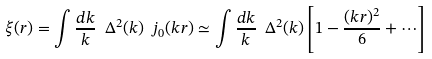<formula> <loc_0><loc_0><loc_500><loc_500>\xi ( r ) = \int \frac { d k } { k } \ \Delta ^ { 2 } ( k ) \ j _ { 0 } ( k r ) \simeq \int \frac { d k } { k } \ \Delta ^ { 2 } ( k ) \left [ 1 - \frac { ( k r ) ^ { 2 } } { 6 } + \cdots \right ]</formula> 